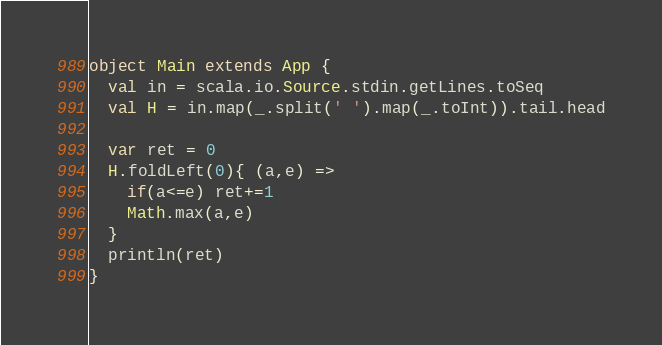<code> <loc_0><loc_0><loc_500><loc_500><_Scala_>object Main extends App {
  val in = scala.io.Source.stdin.getLines.toSeq
  val H = in.map(_.split(' ').map(_.toInt)).tail.head

  var ret = 0
  H.foldLeft(0){ (a,e) =>
    if(a<=e) ret+=1
    Math.max(a,e)
  }
  println(ret)
}
</code> 